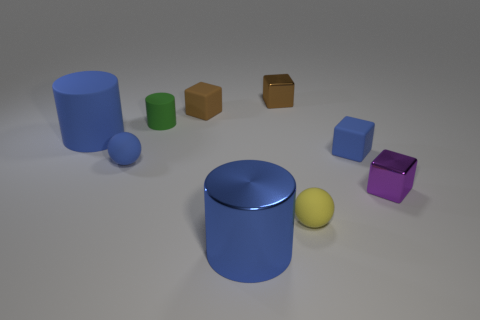How many other objects are the same size as the blue metallic thing?
Give a very brief answer. 1. What number of small things are blue metallic things or yellow shiny spheres?
Provide a succinct answer. 0. Do the brown shiny block and the blue cylinder that is right of the green rubber cylinder have the same size?
Your answer should be very brief. No. What number of other things are the same shape as the purple metal thing?
Your answer should be compact. 3. The tiny brown object that is made of the same material as the small green cylinder is what shape?
Ensure brevity in your answer.  Cube. Is there a sphere?
Keep it short and to the point. Yes. Is the number of tiny brown metallic cubes that are in front of the yellow object less than the number of matte things on the right side of the purple thing?
Give a very brief answer. No. There is a matte object that is in front of the purple shiny thing; what shape is it?
Give a very brief answer. Sphere. Is the material of the blue ball the same as the small green cylinder?
Offer a terse response. Yes. Is there anything else that is the same material as the small cylinder?
Provide a succinct answer. Yes. 